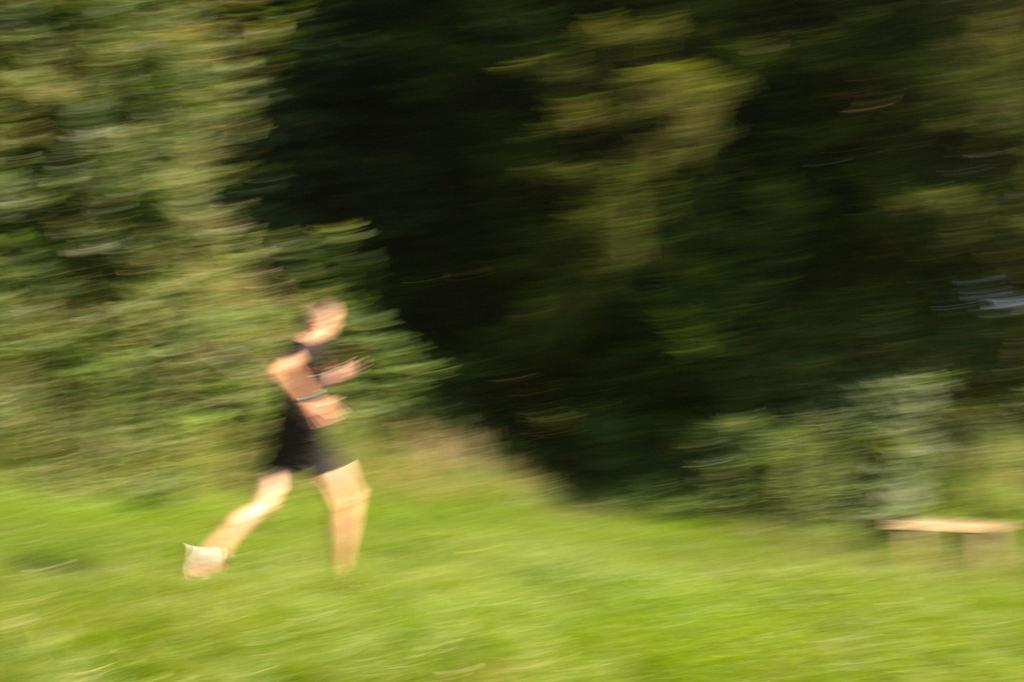What is the main subject of the image? There is a person in the image. What type of natural environment is visible in the image? There are multiple trees in the image. How would you describe the quality of the image? The image is blurry. What type of tooth is being used to create the art in the image? There is no tooth or art present in the image; it features a person and multiple trees. 